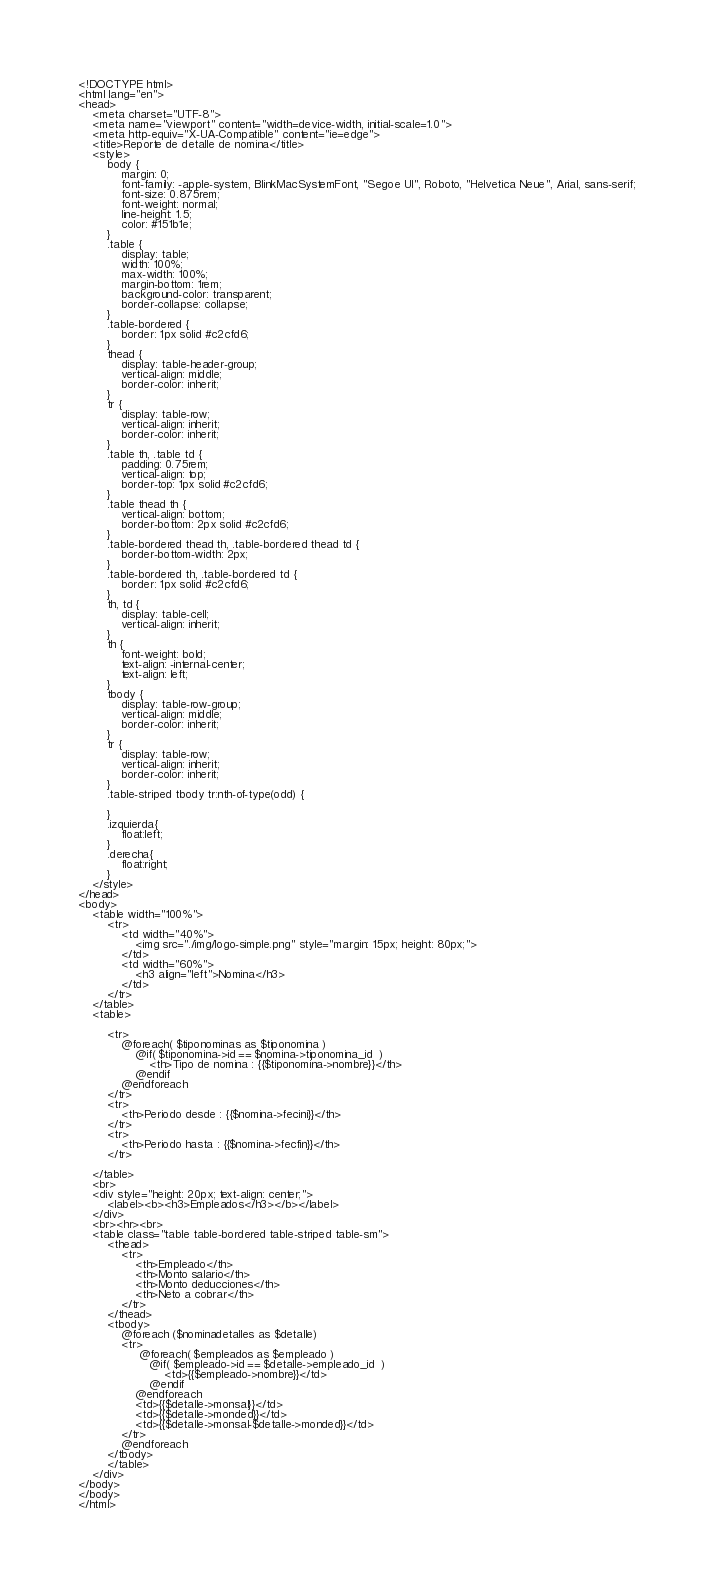<code> <loc_0><loc_0><loc_500><loc_500><_PHP_><!DOCTYPE html>
<html lang="en">
<head>
    <meta charset="UTF-8">
    <meta name="viewport" content="width=device-width, initial-scale=1.0">
    <meta http-equiv="X-UA-Compatible" content="ie=edge">
    <title>Reporte de detalle de nomina</title>
    <style>
        body {
            margin: 0;
            font-family: -apple-system, BlinkMacSystemFont, "Segoe UI", Roboto, "Helvetica Neue", Arial, sans-serif;
            font-size: 0.875rem;
            font-weight: normal;
            line-height: 1.5;
            color: #151b1e;           
        }
        .table {
            display: table;
            width: 100%;
            max-width: 100%;
            margin-bottom: 1rem;
            background-color: transparent;
            border-collapse: collapse;
        }
        .table-bordered {
            border: 1px solid #c2cfd6;
        }
        thead {
            display: table-header-group;
            vertical-align: middle;
            border-color: inherit;
        }
        tr {
            display: table-row;
            vertical-align: inherit;
            border-color: inherit;
        }
        .table th, .table td {
            padding: 0.75rem;
            vertical-align: top;
            border-top: 1px solid #c2cfd6;
        }
        .table thead th {
            vertical-align: bottom;
            border-bottom: 2px solid #c2cfd6;
        }
        .table-bordered thead th, .table-bordered thead td {
            border-bottom-width: 2px;
        }
        .table-bordered th, .table-bordered td {
            border: 1px solid #c2cfd6;
        }
        th, td {
            display: table-cell;
            vertical-align: inherit;
        }
        th {
            font-weight: bold;
            text-align: -internal-center;
            text-align: left;
        }
        tbody {
            display: table-row-group;
            vertical-align: middle;
            border-color: inherit;
        }
        tr {
            display: table-row;
            vertical-align: inherit;
            border-color: inherit;
        }
        .table-striped tbody tr:nth-of-type(odd) {
            
        }
        .izquierda{
            float:left;
        }
        .derecha{
            float:right;
        }
    </style>
</head>
<body>
    <table width="100%">
        <tr>
            <td width="40%">
                <img src="./img/logo-simple.png" style="margin: 15px; height: 80px;">            
            </td>
            <td width="60%">
                <h3 align="left">Nomina</h3>        
            </td>
        </tr>
    </table>      
    <table>
     
        <tr> 
            @foreach( $tiponominas as $tiponomina )
                @if( $tiponomina->id == $nomina->tiponomina_id  )
                    <th>Tipo de nomina : {{$tiponomina->nombre}}</th>
                @endif
            @endforeach
        </tr>
        <tr>
            <th>Periodo desde : {{$nomina->fecini}}</th>
        </tr>
        <tr>
            <th>Periodo hasta : {{$nomina->fecfin}}</th>
        </tr>               
                  
    </table>
    <br>
    <div style="height: 20px; text-align: center;">
        <label><b><h3>Empleados</h3></b></label>
    </div>
    <br><hr><br>
    <table class="table table-bordered table-striped table-sm">
        <thead>
            <tr>
                <th>Empleado</th>
                <th>Monto salario</th>
                <th>Monto deducciones</th>
                <th>Neto a cobrar</th>                
            </tr>                   
        </thead>
        <tbody>            
            @foreach ($nominadetalles as $detalle)
            <tr>                    
                 @foreach( $empleados as $empleado )
                    @if( $empleado->id == $detalle->empleado_id  )
                        <td>{{$empleado->nombre}}</td>
                    @endif
                @endforeach
                <td>{{$detalle->monsal}}</td>                    
                <td>{{$detalle->monded}}</td>
                <td>{{$detalle->monsal-$detalle->monded}}</td>
            </tr>
            @endforeach                               
        </tbody>
        </table>
    </div>    
</body>
</body>
</html></code> 